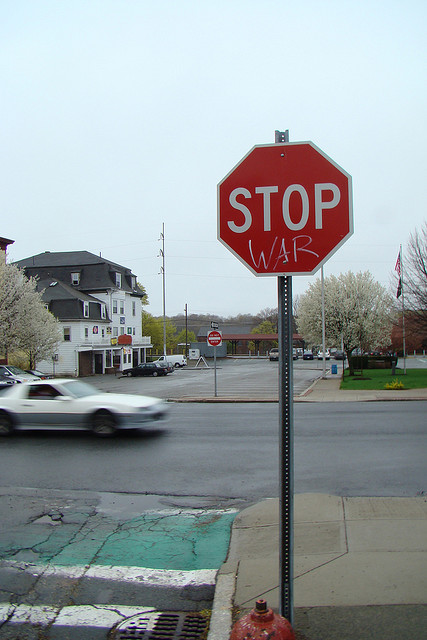How common is it for public signs to be used like this for activism? Using public signs for activism, such as this 'STOP WAR' message on a stop sign, is a notable method seen in urban and activist contexts. It taps into the visibility and familiarity of traffic signage to convey powerful messages succinctly and impactfully. While not routine, such alterations are part of a broader trend in guerrilla art and political expression. They are seen globally in various forms to raise awareness and challenge the status quo. 